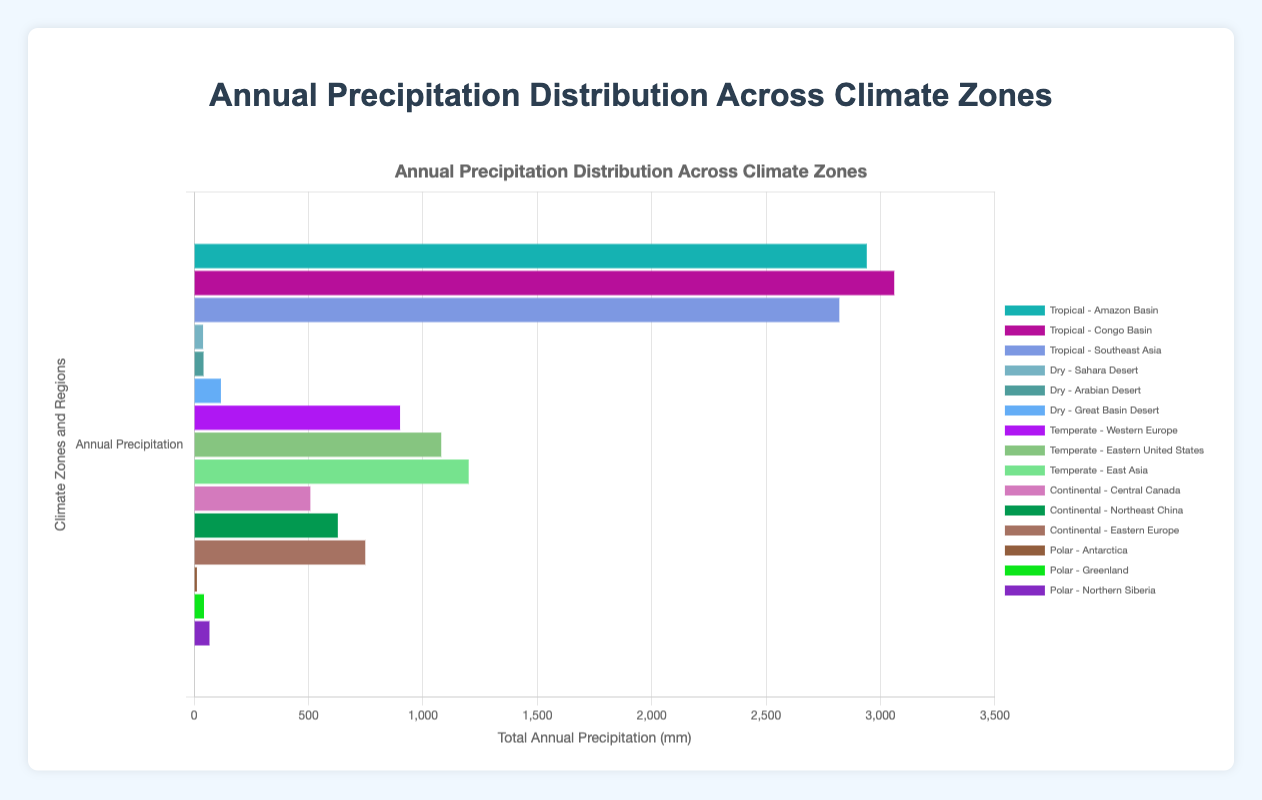What is the total annual precipitation in the Amazon Basin? To find the total annual precipitation, sum up all the monthly values: 240 + 220 + 200 + 190 + 260 + 270 + 250 + 260 + 280 + 300 + 230 + 240 = 2940 mm
Answer: 2940 mm Which region, Sahara Desert or Eastern Europe, has a higher total annual precipitation? First calculate the total annual precipitation for each region. Sahara Desert: 2 + 5 + 6 + 8 + 3 + 1 + 0 + 2 + 0 + 4 + 3 + 5 = 39 mm. Eastern Europe: 60 + 55 + 50 + 45 + 65 + 70 + 75 + 70 + 67 + 72 + 62 + 57 = 748 mm. Compare the two totals; Eastern Europe has a much higher total precipitation.
Answer: Eastern Europe What is the average annual precipitation for the regions in the Polar climate zone? First, sum the total annual precipitation for each region in the Polar climate zone: Antarctica: 17 mm, Greenland: 38 mm, Northern Siberia: 66 mm. Then, compute the average: (17 + 38 + 66) / 3 = 40.33 mm
Answer: 40.33 mm Which climate zone has the lowest total annual precipitation across all regions? Calculate the total annual precipitation for each climate zone. Tropical: 8320 mm, Dry: 159 mm, Temperate: 3180 mm, Continental: 1730 mm, Polar: 121 mm. The Polar climate zone has the lowest total annual precipitation.
Answer: Polar What is the difference in total annual precipitation between Southeast Asia and Western Europe? Calculate the total annual precipitation for Southeast Asia and Western Europe. Southeast Asia: 2800 mm, Western Europe: 900 mm. The difference is 2800 - 900 = 1900 mm
Answer: 1900 mm Is the total annual precipitation of the Amazon Basin greater than the combined total of Sahara Desert and Arabian Desert? First, calculate the totals for each region: Amazon Basin: 2940 mm, Sahara Desert: 39 mm, Arabian Desert: 41 mm. Comparing 2940 mm and 80 mm, the Amazon Basin has a significantly greater total annual precipitation.
Answer: Yes How does the total annual precipitation for Congo Basin compare visually to that for East Asia? Visually inspect the lengths of the horizontal bars or refer to their total values. Congo Basin: 3200 mm, East Asia: 1325 mm. The Congo Basin's bar is noticeably longer, indicating higher annual precipitation.
Answer: Congo Basin has greater precipitation What is the range of annual precipitation for Northeast China? The range is found by subtracting the minimum monthly value from the maximum monthly value: 62 - 35 = 27 mm
Answer: 27 mm Which region in the Temperate zone has the highest total annual precipitation? Compare the total annual precipitation of Western Europe, Eastern United States, and East Asia. Western Europe: 900 mm, Eastern United States: 1080 mm, East Asia: 1140 mm. East Asia has the highest total.
Answer: East Asia 